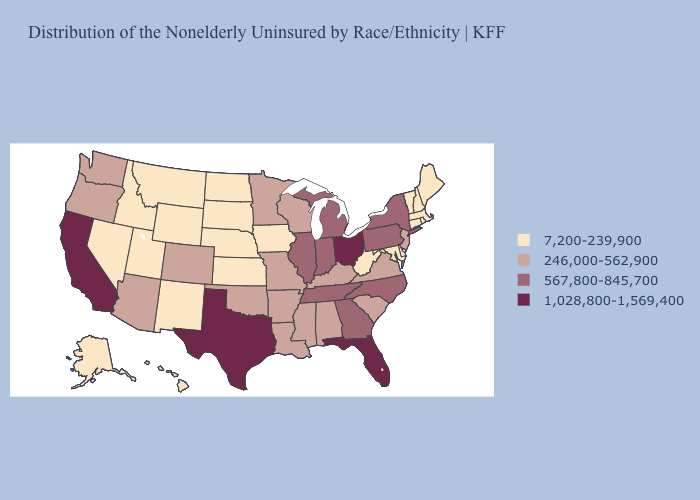Is the legend a continuous bar?
Be succinct. No. Which states have the lowest value in the USA?
Write a very short answer. Alaska, Connecticut, Delaware, Hawaii, Idaho, Iowa, Kansas, Maine, Maryland, Massachusetts, Montana, Nebraska, Nevada, New Hampshire, New Mexico, North Dakota, Rhode Island, South Dakota, Utah, Vermont, West Virginia, Wyoming. Name the states that have a value in the range 1,028,800-1,569,400?
Short answer required. California, Florida, Ohio, Texas. Does Wyoming have a higher value than Alaska?
Write a very short answer. No. Does the first symbol in the legend represent the smallest category?
Keep it brief. Yes. Name the states that have a value in the range 567,800-845,700?
Be succinct. Georgia, Illinois, Indiana, Michigan, New York, North Carolina, Pennsylvania, Tennessee. Does Nebraska have the lowest value in the USA?
Keep it brief. Yes. What is the highest value in the USA?
Be succinct. 1,028,800-1,569,400. Which states have the lowest value in the USA?
Give a very brief answer. Alaska, Connecticut, Delaware, Hawaii, Idaho, Iowa, Kansas, Maine, Maryland, Massachusetts, Montana, Nebraska, Nevada, New Hampshire, New Mexico, North Dakota, Rhode Island, South Dakota, Utah, Vermont, West Virginia, Wyoming. How many symbols are there in the legend?
Concise answer only. 4. What is the highest value in states that border Indiana?
Answer briefly. 1,028,800-1,569,400. Does Alaska have the lowest value in the USA?
Keep it brief. Yes. What is the highest value in the Northeast ?
Write a very short answer. 567,800-845,700. Name the states that have a value in the range 7,200-239,900?
Give a very brief answer. Alaska, Connecticut, Delaware, Hawaii, Idaho, Iowa, Kansas, Maine, Maryland, Massachusetts, Montana, Nebraska, Nevada, New Hampshire, New Mexico, North Dakota, Rhode Island, South Dakota, Utah, Vermont, West Virginia, Wyoming. 